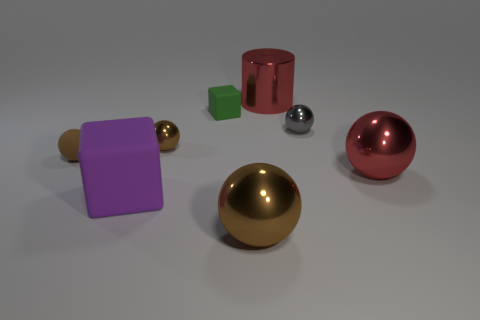Subtract all red cylinders. How many brown spheres are left? 3 Subtract all large red metallic spheres. How many spheres are left? 4 Subtract all red balls. How many balls are left? 4 Add 2 small things. How many objects exist? 10 Subtract all spheres. How many objects are left? 3 Subtract all green spheres. Subtract all gray cylinders. How many spheres are left? 5 Add 3 tiny rubber objects. How many tiny rubber objects are left? 5 Add 3 large red shiny balls. How many large red shiny balls exist? 4 Subtract 0 yellow spheres. How many objects are left? 8 Subtract all tiny green rubber things. Subtract all big blocks. How many objects are left? 6 